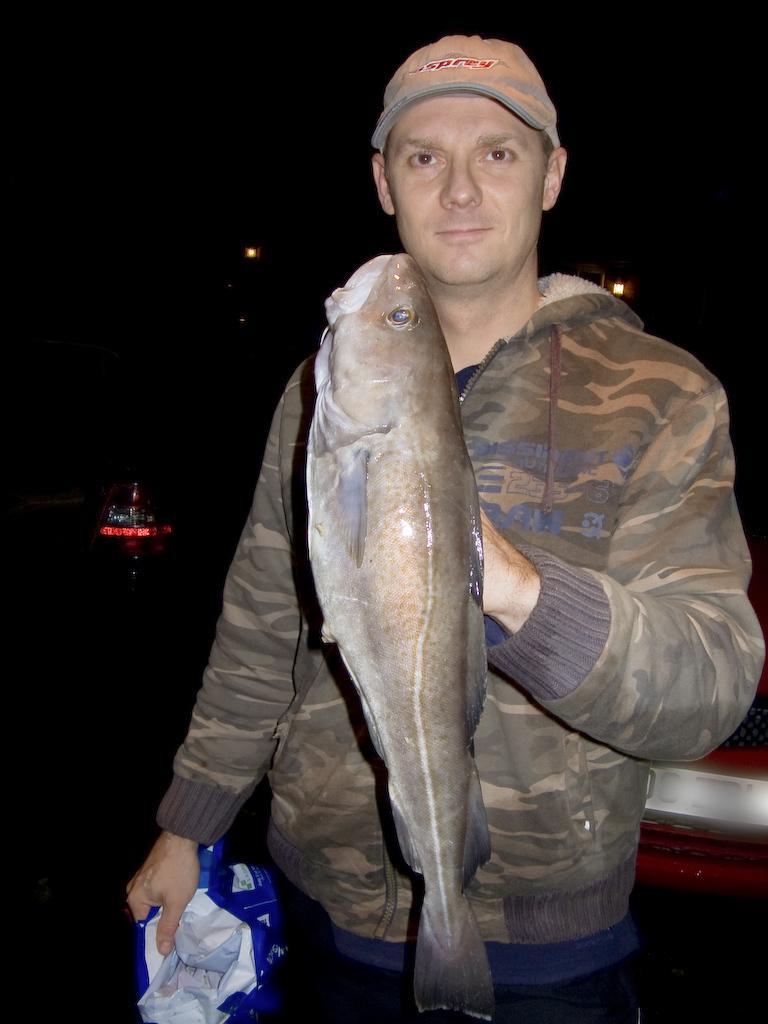How would you summarize this image in a sentence or two? Here I can see a man wearing a jacket, cap on the head, holding a fish and other object in the hands and giving pose for the picture. The background is in black color. 